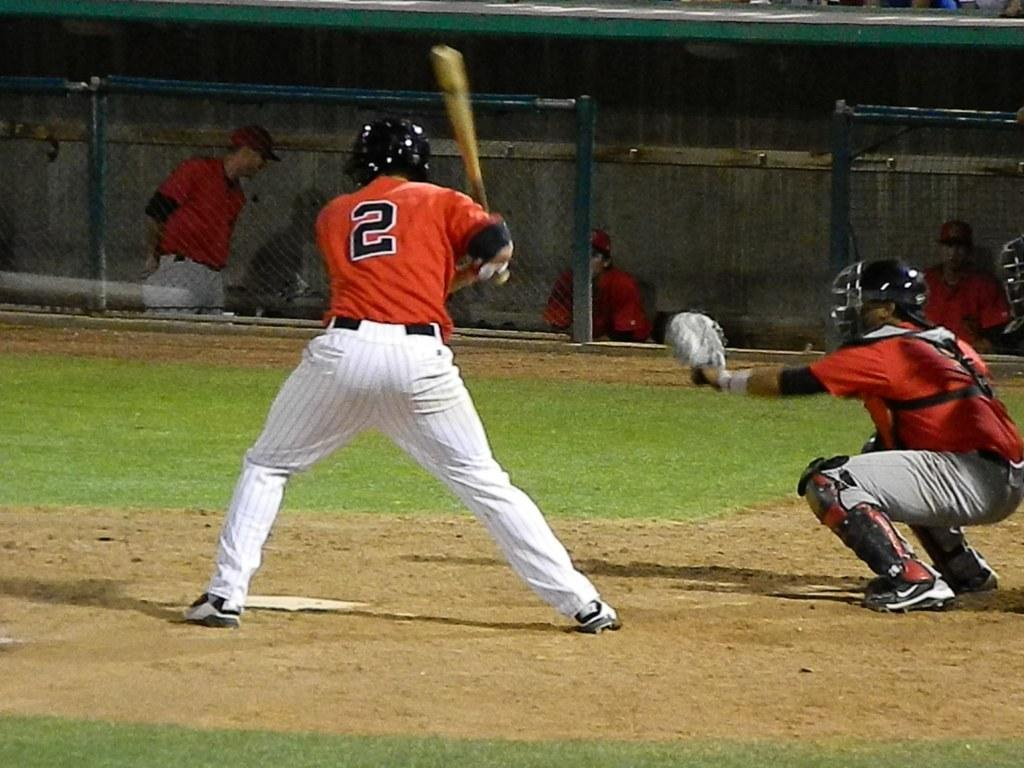Provide a one-sentence caption for the provided image. A baseball player in an orange jersey with the number 2 prepares to swing at the ball. 